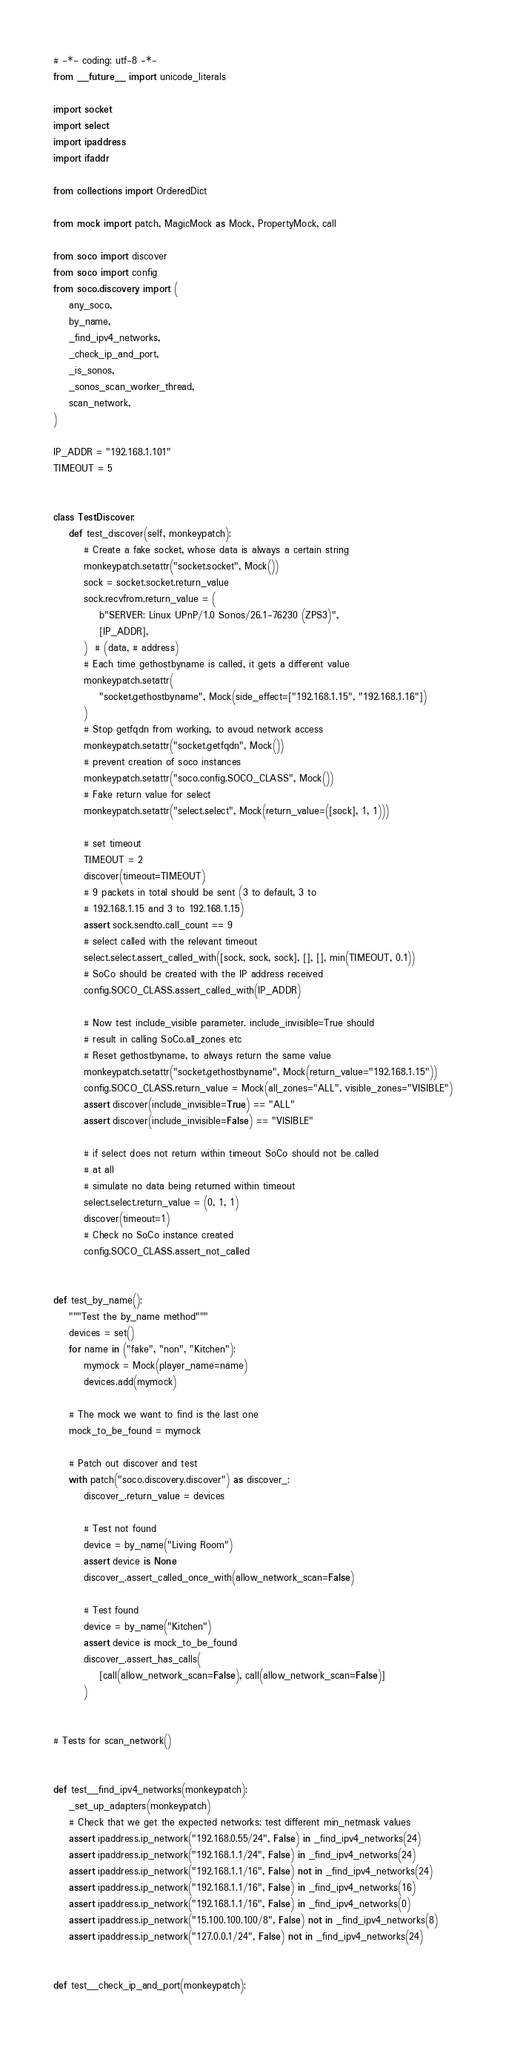Convert code to text. <code><loc_0><loc_0><loc_500><loc_500><_Python_># -*- coding: utf-8 -*-
from __future__ import unicode_literals

import socket
import select
import ipaddress
import ifaddr

from collections import OrderedDict

from mock import patch, MagicMock as Mock, PropertyMock, call

from soco import discover
from soco import config
from soco.discovery import (
    any_soco,
    by_name,
    _find_ipv4_networks,
    _check_ip_and_port,
    _is_sonos,
    _sonos_scan_worker_thread,
    scan_network,
)

IP_ADDR = "192.168.1.101"
TIMEOUT = 5


class TestDiscover:
    def test_discover(self, monkeypatch):
        # Create a fake socket, whose data is always a certain string
        monkeypatch.setattr("socket.socket", Mock())
        sock = socket.socket.return_value
        sock.recvfrom.return_value = (
            b"SERVER: Linux UPnP/1.0 Sonos/26.1-76230 (ZPS3)",
            [IP_ADDR],
        )  # (data, # address)
        # Each time gethostbyname is called, it gets a different value
        monkeypatch.setattr(
            "socket.gethostbyname", Mock(side_effect=["192.168.1.15", "192.168.1.16"])
        )
        # Stop getfqdn from working, to avoud network access
        monkeypatch.setattr("socket.getfqdn", Mock())
        # prevent creation of soco instances
        monkeypatch.setattr("soco.config.SOCO_CLASS", Mock())
        # Fake return value for select
        monkeypatch.setattr("select.select", Mock(return_value=([sock], 1, 1)))

        # set timeout
        TIMEOUT = 2
        discover(timeout=TIMEOUT)
        # 9 packets in total should be sent (3 to default, 3 to
        # 192.168.1.15 and 3 to 192.168.1.15)
        assert sock.sendto.call_count == 9
        # select called with the relevant timeout
        select.select.assert_called_with([sock, sock, sock], [], [], min(TIMEOUT, 0.1))
        # SoCo should be created with the IP address received
        config.SOCO_CLASS.assert_called_with(IP_ADDR)

        # Now test include_visible parameter. include_invisible=True should
        # result in calling SoCo.all_zones etc
        # Reset gethostbyname, to always return the same value
        monkeypatch.setattr("socket.gethostbyname", Mock(return_value="192.168.1.15"))
        config.SOCO_CLASS.return_value = Mock(all_zones="ALL", visible_zones="VISIBLE")
        assert discover(include_invisible=True) == "ALL"
        assert discover(include_invisible=False) == "VISIBLE"

        # if select does not return within timeout SoCo should not be called
        # at all
        # simulate no data being returned within timeout
        select.select.return_value = (0, 1, 1)
        discover(timeout=1)
        # Check no SoCo instance created
        config.SOCO_CLASS.assert_not_called


def test_by_name():
    """Test the by_name method"""
    devices = set()
    for name in ("fake", "non", "Kitchen"):
        mymock = Mock(player_name=name)
        devices.add(mymock)

    # The mock we want to find is the last one
    mock_to_be_found = mymock

    # Patch out discover and test
    with patch("soco.discovery.discover") as discover_:
        discover_.return_value = devices

        # Test not found
        device = by_name("Living Room")
        assert device is None
        discover_.assert_called_once_with(allow_network_scan=False)

        # Test found
        device = by_name("Kitchen")
        assert device is mock_to_be_found
        discover_.assert_has_calls(
            [call(allow_network_scan=False), call(allow_network_scan=False)]
        )


# Tests for scan_network()


def test__find_ipv4_networks(monkeypatch):
    _set_up_adapters(monkeypatch)
    # Check that we get the expected networks; test different min_netmask values
    assert ipaddress.ip_network("192.168.0.55/24", False) in _find_ipv4_networks(24)
    assert ipaddress.ip_network("192.168.1.1/24", False) in _find_ipv4_networks(24)
    assert ipaddress.ip_network("192.168.1.1/16", False) not in _find_ipv4_networks(24)
    assert ipaddress.ip_network("192.168.1.1/16", False) in _find_ipv4_networks(16)
    assert ipaddress.ip_network("192.168.1.1/16", False) in _find_ipv4_networks(0)
    assert ipaddress.ip_network("15.100.100.100/8", False) not in _find_ipv4_networks(8)
    assert ipaddress.ip_network("127.0.0.1/24", False) not in _find_ipv4_networks(24)


def test__check_ip_and_port(monkeypatch):</code> 